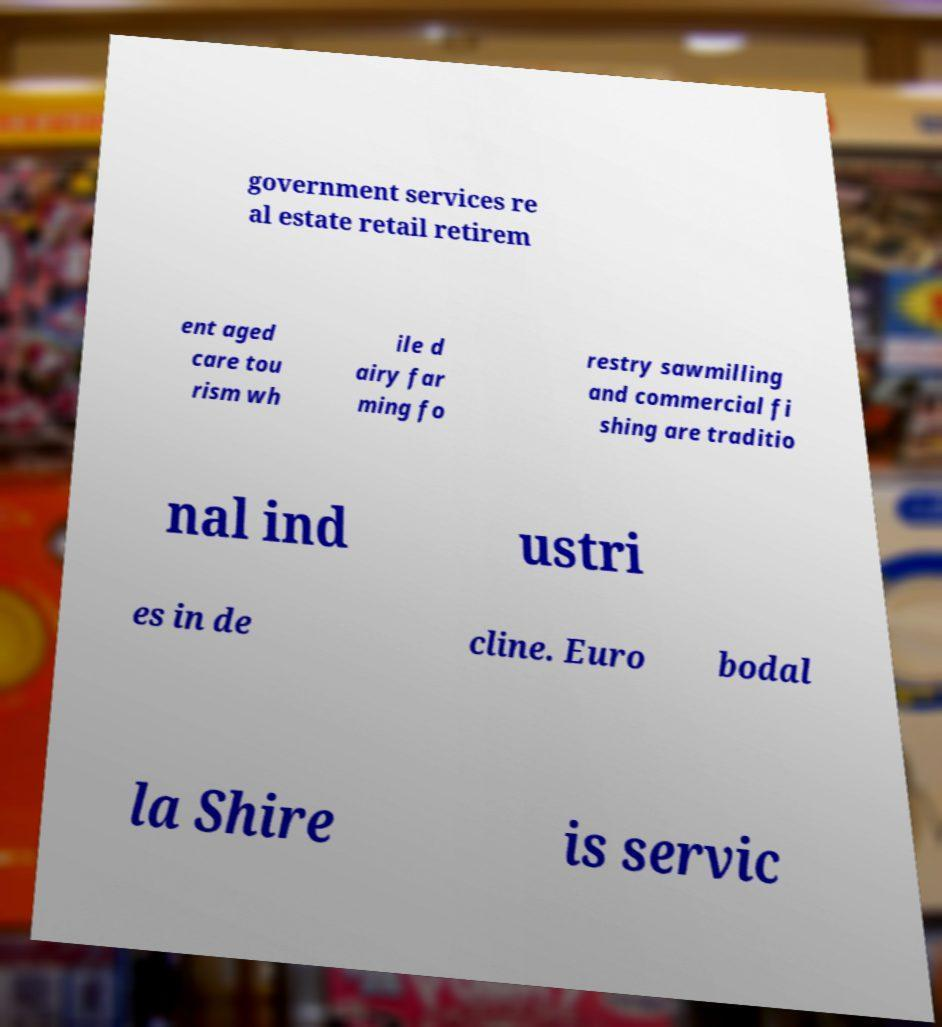What messages or text are displayed in this image? I need them in a readable, typed format. government services re al estate retail retirem ent aged care tou rism wh ile d airy far ming fo restry sawmilling and commercial fi shing are traditio nal ind ustri es in de cline. Euro bodal la Shire is servic 